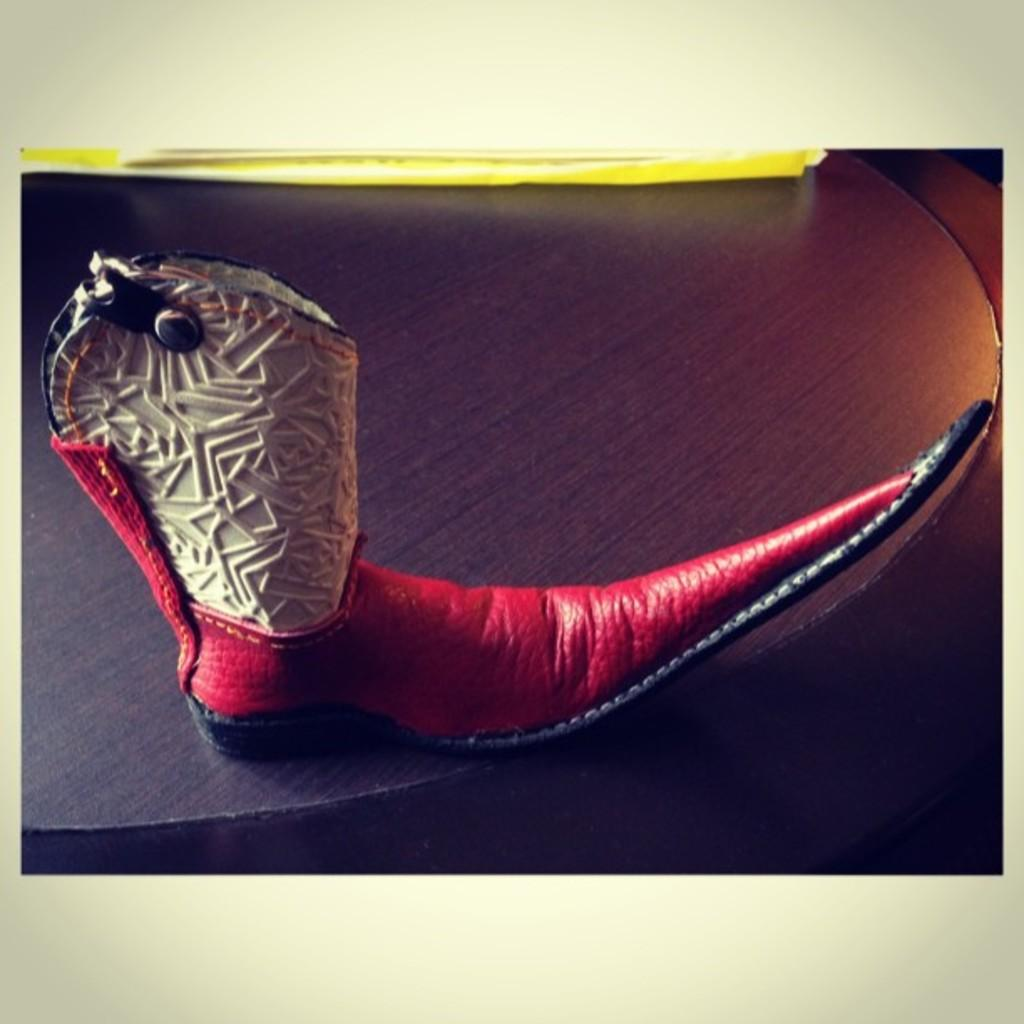What is the color of the shoes in the image? The shoes are red in color. What type of cream is being used to paint the shoes in the image? There is no cream or painting activity present in the image; the shoes are simply red in color. 